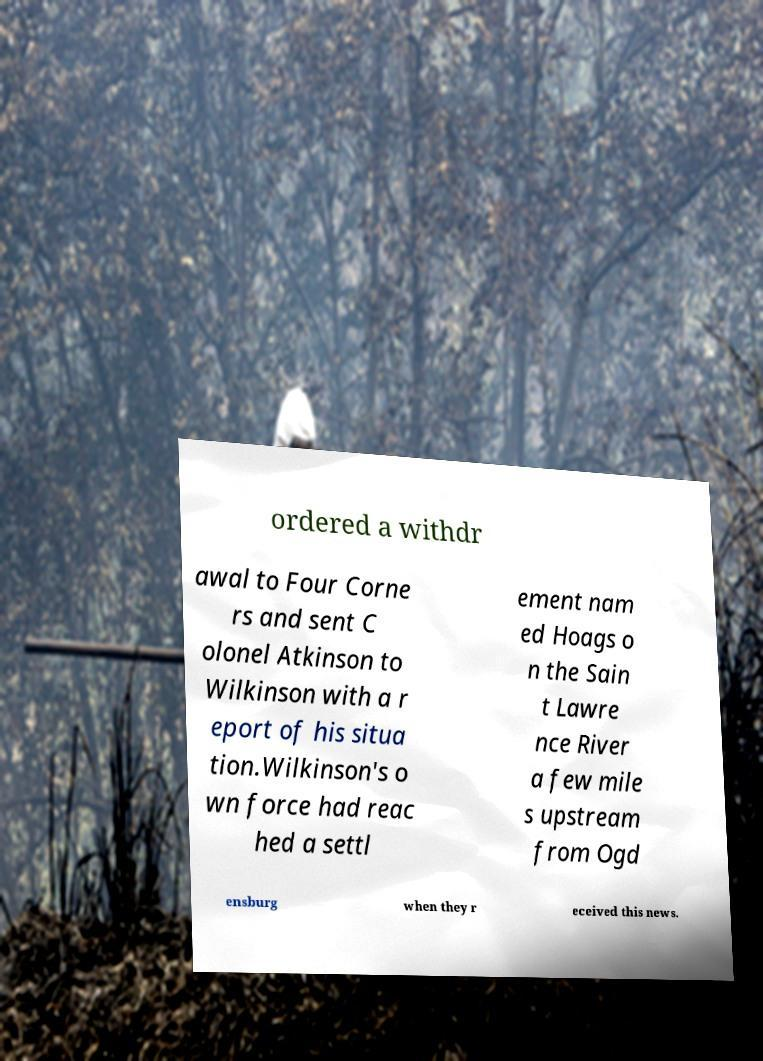For documentation purposes, I need the text within this image transcribed. Could you provide that? ordered a withdr awal to Four Corne rs and sent C olonel Atkinson to Wilkinson with a r eport of his situa tion.Wilkinson's o wn force had reac hed a settl ement nam ed Hoags o n the Sain t Lawre nce River a few mile s upstream from Ogd ensburg when they r eceived this news. 